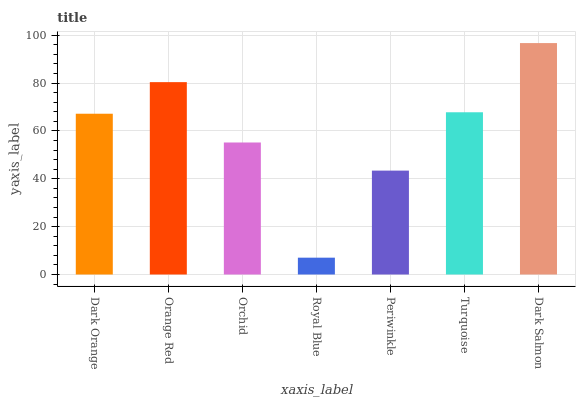Is Royal Blue the minimum?
Answer yes or no. Yes. Is Dark Salmon the maximum?
Answer yes or no. Yes. Is Orange Red the minimum?
Answer yes or no. No. Is Orange Red the maximum?
Answer yes or no. No. Is Orange Red greater than Dark Orange?
Answer yes or no. Yes. Is Dark Orange less than Orange Red?
Answer yes or no. Yes. Is Dark Orange greater than Orange Red?
Answer yes or no. No. Is Orange Red less than Dark Orange?
Answer yes or no. No. Is Dark Orange the high median?
Answer yes or no. Yes. Is Dark Orange the low median?
Answer yes or no. Yes. Is Royal Blue the high median?
Answer yes or no. No. Is Dark Salmon the low median?
Answer yes or no. No. 